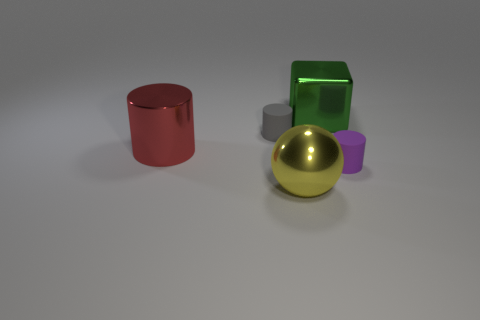Add 2 small purple cylinders. How many objects exist? 7 Subtract all spheres. How many objects are left? 4 Add 3 big green cubes. How many big green cubes exist? 4 Subtract 0 blue cylinders. How many objects are left? 5 Subtract all yellow shiny objects. Subtract all large yellow balls. How many objects are left? 3 Add 5 purple objects. How many purple objects are left? 6 